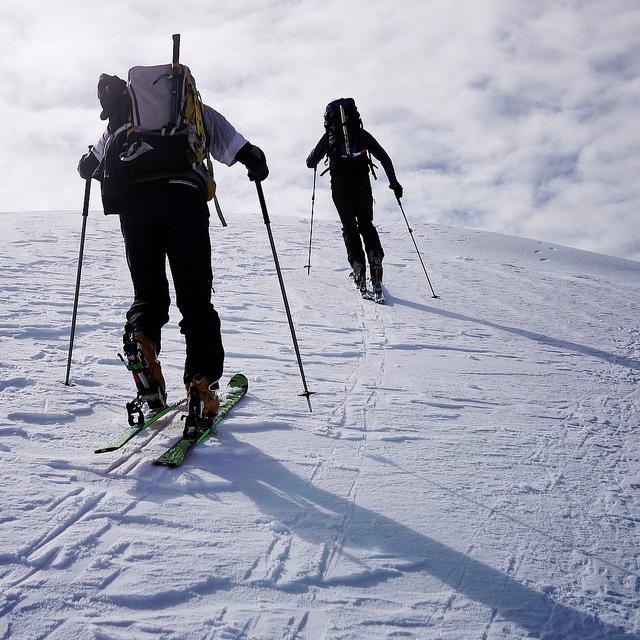Does the snow look deep?
Keep it brief. No. Do these people have backpacks?
Quick response, please. Yes. Are the skiers going downhill?
Answer briefly. No. 